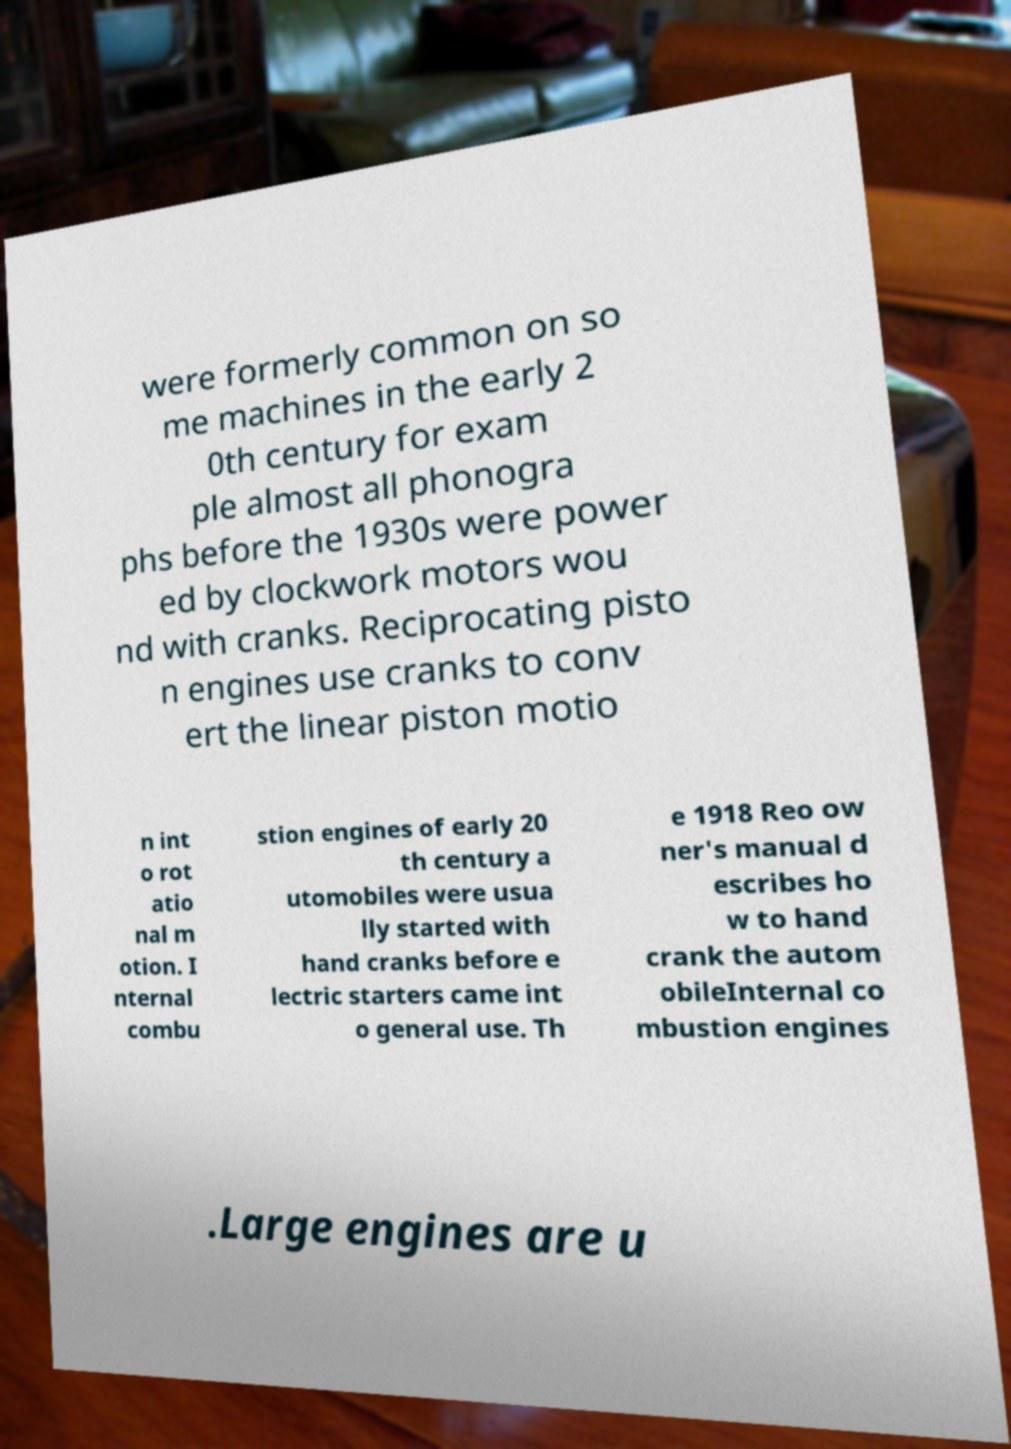Please read and relay the text visible in this image. What does it say? were formerly common on so me machines in the early 2 0th century for exam ple almost all phonogra phs before the 1930s were power ed by clockwork motors wou nd with cranks. Reciprocating pisto n engines use cranks to conv ert the linear piston motio n int o rot atio nal m otion. I nternal combu stion engines of early 20 th century a utomobiles were usua lly started with hand cranks before e lectric starters came int o general use. Th e 1918 Reo ow ner's manual d escribes ho w to hand crank the autom obileInternal co mbustion engines .Large engines are u 